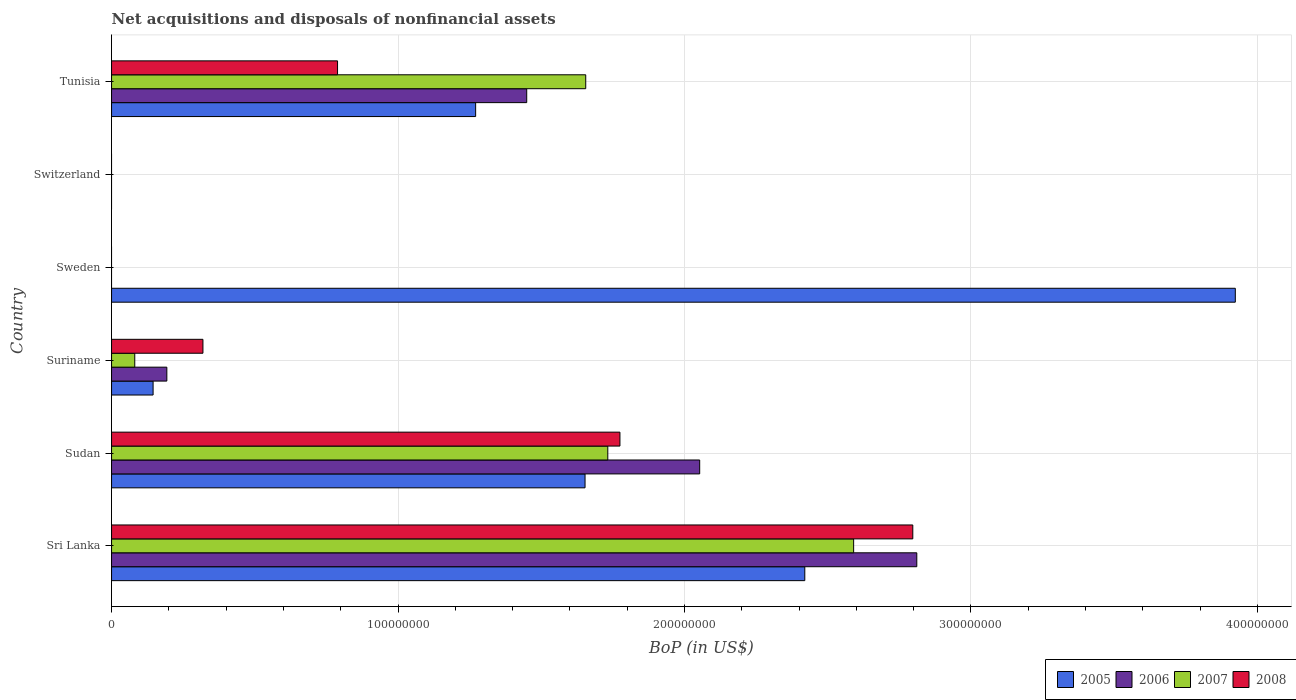How many different coloured bars are there?
Your answer should be compact. 4. Are the number of bars per tick equal to the number of legend labels?
Make the answer very short. No. What is the label of the 3rd group of bars from the top?
Your response must be concise. Sweden. In how many cases, is the number of bars for a given country not equal to the number of legend labels?
Provide a succinct answer. 2. What is the Balance of Payments in 2005 in Sri Lanka?
Provide a short and direct response. 2.42e+08. Across all countries, what is the maximum Balance of Payments in 2007?
Offer a terse response. 2.59e+08. Across all countries, what is the minimum Balance of Payments in 2006?
Your response must be concise. 0. What is the total Balance of Payments in 2005 in the graph?
Keep it short and to the point. 9.41e+08. What is the difference between the Balance of Payments in 2008 in Sri Lanka and that in Suriname?
Your answer should be compact. 2.48e+08. What is the difference between the Balance of Payments in 2005 in Switzerland and the Balance of Payments in 2008 in Sudan?
Make the answer very short. -1.77e+08. What is the average Balance of Payments in 2006 per country?
Ensure brevity in your answer.  1.08e+08. What is the difference between the Balance of Payments in 2008 and Balance of Payments in 2005 in Tunisia?
Offer a very short reply. -4.82e+07. In how many countries, is the Balance of Payments in 2005 greater than 300000000 US$?
Your response must be concise. 1. What is the ratio of the Balance of Payments in 2006 in Sri Lanka to that in Sudan?
Provide a succinct answer. 1.37. Is the Balance of Payments in 2006 in Suriname less than that in Tunisia?
Ensure brevity in your answer.  Yes. Is the difference between the Balance of Payments in 2008 in Suriname and Tunisia greater than the difference between the Balance of Payments in 2005 in Suriname and Tunisia?
Offer a very short reply. Yes. What is the difference between the highest and the second highest Balance of Payments in 2007?
Offer a very short reply. 8.58e+07. What is the difference between the highest and the lowest Balance of Payments in 2008?
Make the answer very short. 2.80e+08. Is the sum of the Balance of Payments in 2005 in Sudan and Sweden greater than the maximum Balance of Payments in 2008 across all countries?
Your answer should be very brief. Yes. Is it the case that in every country, the sum of the Balance of Payments in 2005 and Balance of Payments in 2008 is greater than the sum of Balance of Payments in 2006 and Balance of Payments in 2007?
Your answer should be very brief. No. Is it the case that in every country, the sum of the Balance of Payments in 2006 and Balance of Payments in 2008 is greater than the Balance of Payments in 2007?
Your response must be concise. No. How many countries are there in the graph?
Offer a very short reply. 6. What is the difference between two consecutive major ticks on the X-axis?
Offer a very short reply. 1.00e+08. Does the graph contain any zero values?
Provide a succinct answer. Yes. Where does the legend appear in the graph?
Ensure brevity in your answer.  Bottom right. What is the title of the graph?
Provide a succinct answer. Net acquisitions and disposals of nonfinancial assets. What is the label or title of the X-axis?
Make the answer very short. BoP (in US$). What is the label or title of the Y-axis?
Provide a short and direct response. Country. What is the BoP (in US$) in 2005 in Sri Lanka?
Provide a short and direct response. 2.42e+08. What is the BoP (in US$) in 2006 in Sri Lanka?
Give a very brief answer. 2.81e+08. What is the BoP (in US$) of 2007 in Sri Lanka?
Provide a short and direct response. 2.59e+08. What is the BoP (in US$) in 2008 in Sri Lanka?
Your response must be concise. 2.80e+08. What is the BoP (in US$) of 2005 in Sudan?
Your answer should be very brief. 1.65e+08. What is the BoP (in US$) of 2006 in Sudan?
Ensure brevity in your answer.  2.05e+08. What is the BoP (in US$) of 2007 in Sudan?
Provide a short and direct response. 1.73e+08. What is the BoP (in US$) of 2008 in Sudan?
Your answer should be very brief. 1.77e+08. What is the BoP (in US$) in 2005 in Suriname?
Give a very brief answer. 1.45e+07. What is the BoP (in US$) in 2006 in Suriname?
Provide a short and direct response. 1.93e+07. What is the BoP (in US$) of 2007 in Suriname?
Give a very brief answer. 8.10e+06. What is the BoP (in US$) in 2008 in Suriname?
Your answer should be compact. 3.19e+07. What is the BoP (in US$) in 2005 in Sweden?
Make the answer very short. 3.92e+08. What is the BoP (in US$) of 2008 in Sweden?
Provide a succinct answer. 0. What is the BoP (in US$) in 2005 in Switzerland?
Your response must be concise. 0. What is the BoP (in US$) in 2005 in Tunisia?
Offer a terse response. 1.27e+08. What is the BoP (in US$) in 2006 in Tunisia?
Offer a terse response. 1.45e+08. What is the BoP (in US$) of 2007 in Tunisia?
Provide a succinct answer. 1.66e+08. What is the BoP (in US$) of 2008 in Tunisia?
Offer a terse response. 7.89e+07. Across all countries, what is the maximum BoP (in US$) of 2005?
Ensure brevity in your answer.  3.92e+08. Across all countries, what is the maximum BoP (in US$) in 2006?
Ensure brevity in your answer.  2.81e+08. Across all countries, what is the maximum BoP (in US$) in 2007?
Ensure brevity in your answer.  2.59e+08. Across all countries, what is the maximum BoP (in US$) of 2008?
Ensure brevity in your answer.  2.80e+08. What is the total BoP (in US$) of 2005 in the graph?
Your response must be concise. 9.41e+08. What is the total BoP (in US$) in 2006 in the graph?
Keep it short and to the point. 6.51e+08. What is the total BoP (in US$) in 2007 in the graph?
Your answer should be very brief. 6.06e+08. What is the total BoP (in US$) of 2008 in the graph?
Offer a terse response. 5.68e+08. What is the difference between the BoP (in US$) of 2005 in Sri Lanka and that in Sudan?
Ensure brevity in your answer.  7.67e+07. What is the difference between the BoP (in US$) of 2006 in Sri Lanka and that in Sudan?
Offer a very short reply. 7.58e+07. What is the difference between the BoP (in US$) in 2007 in Sri Lanka and that in Sudan?
Provide a short and direct response. 8.58e+07. What is the difference between the BoP (in US$) of 2008 in Sri Lanka and that in Sudan?
Your answer should be compact. 1.02e+08. What is the difference between the BoP (in US$) of 2005 in Sri Lanka and that in Suriname?
Provide a succinct answer. 2.28e+08. What is the difference between the BoP (in US$) of 2006 in Sri Lanka and that in Suriname?
Offer a very short reply. 2.62e+08. What is the difference between the BoP (in US$) in 2007 in Sri Lanka and that in Suriname?
Provide a succinct answer. 2.51e+08. What is the difference between the BoP (in US$) in 2008 in Sri Lanka and that in Suriname?
Give a very brief answer. 2.48e+08. What is the difference between the BoP (in US$) in 2005 in Sri Lanka and that in Sweden?
Offer a terse response. -1.50e+08. What is the difference between the BoP (in US$) of 2005 in Sri Lanka and that in Tunisia?
Offer a very short reply. 1.15e+08. What is the difference between the BoP (in US$) in 2006 in Sri Lanka and that in Tunisia?
Keep it short and to the point. 1.36e+08. What is the difference between the BoP (in US$) of 2007 in Sri Lanka and that in Tunisia?
Keep it short and to the point. 9.35e+07. What is the difference between the BoP (in US$) of 2008 in Sri Lanka and that in Tunisia?
Offer a very short reply. 2.01e+08. What is the difference between the BoP (in US$) in 2005 in Sudan and that in Suriname?
Your answer should be compact. 1.51e+08. What is the difference between the BoP (in US$) in 2006 in Sudan and that in Suriname?
Offer a terse response. 1.86e+08. What is the difference between the BoP (in US$) of 2007 in Sudan and that in Suriname?
Provide a succinct answer. 1.65e+08. What is the difference between the BoP (in US$) in 2008 in Sudan and that in Suriname?
Your answer should be very brief. 1.46e+08. What is the difference between the BoP (in US$) of 2005 in Sudan and that in Sweden?
Make the answer very short. -2.27e+08. What is the difference between the BoP (in US$) of 2005 in Sudan and that in Tunisia?
Ensure brevity in your answer.  3.82e+07. What is the difference between the BoP (in US$) of 2006 in Sudan and that in Tunisia?
Offer a very short reply. 6.04e+07. What is the difference between the BoP (in US$) of 2007 in Sudan and that in Tunisia?
Give a very brief answer. 7.70e+06. What is the difference between the BoP (in US$) of 2008 in Sudan and that in Tunisia?
Provide a short and direct response. 9.86e+07. What is the difference between the BoP (in US$) in 2005 in Suriname and that in Sweden?
Keep it short and to the point. -3.78e+08. What is the difference between the BoP (in US$) in 2005 in Suriname and that in Tunisia?
Give a very brief answer. -1.13e+08. What is the difference between the BoP (in US$) of 2006 in Suriname and that in Tunisia?
Your response must be concise. -1.26e+08. What is the difference between the BoP (in US$) in 2007 in Suriname and that in Tunisia?
Give a very brief answer. -1.57e+08. What is the difference between the BoP (in US$) of 2008 in Suriname and that in Tunisia?
Your answer should be very brief. -4.70e+07. What is the difference between the BoP (in US$) of 2005 in Sweden and that in Tunisia?
Provide a succinct answer. 2.65e+08. What is the difference between the BoP (in US$) in 2005 in Sri Lanka and the BoP (in US$) in 2006 in Sudan?
Give a very brief answer. 3.67e+07. What is the difference between the BoP (in US$) in 2005 in Sri Lanka and the BoP (in US$) in 2007 in Sudan?
Keep it short and to the point. 6.88e+07. What is the difference between the BoP (in US$) in 2005 in Sri Lanka and the BoP (in US$) in 2008 in Sudan?
Offer a very short reply. 6.45e+07. What is the difference between the BoP (in US$) of 2006 in Sri Lanka and the BoP (in US$) of 2007 in Sudan?
Provide a succinct answer. 1.08e+08. What is the difference between the BoP (in US$) in 2006 in Sri Lanka and the BoP (in US$) in 2008 in Sudan?
Give a very brief answer. 1.04e+08. What is the difference between the BoP (in US$) of 2007 in Sri Lanka and the BoP (in US$) of 2008 in Sudan?
Your response must be concise. 8.16e+07. What is the difference between the BoP (in US$) in 2005 in Sri Lanka and the BoP (in US$) in 2006 in Suriname?
Your response must be concise. 2.23e+08. What is the difference between the BoP (in US$) in 2005 in Sri Lanka and the BoP (in US$) in 2007 in Suriname?
Provide a short and direct response. 2.34e+08. What is the difference between the BoP (in US$) in 2005 in Sri Lanka and the BoP (in US$) in 2008 in Suriname?
Your answer should be compact. 2.10e+08. What is the difference between the BoP (in US$) in 2006 in Sri Lanka and the BoP (in US$) in 2007 in Suriname?
Offer a terse response. 2.73e+08. What is the difference between the BoP (in US$) of 2006 in Sri Lanka and the BoP (in US$) of 2008 in Suriname?
Offer a very short reply. 2.49e+08. What is the difference between the BoP (in US$) of 2007 in Sri Lanka and the BoP (in US$) of 2008 in Suriname?
Provide a succinct answer. 2.27e+08. What is the difference between the BoP (in US$) in 2005 in Sri Lanka and the BoP (in US$) in 2006 in Tunisia?
Offer a very short reply. 9.71e+07. What is the difference between the BoP (in US$) in 2005 in Sri Lanka and the BoP (in US$) in 2007 in Tunisia?
Offer a terse response. 7.65e+07. What is the difference between the BoP (in US$) of 2005 in Sri Lanka and the BoP (in US$) of 2008 in Tunisia?
Provide a succinct answer. 1.63e+08. What is the difference between the BoP (in US$) in 2006 in Sri Lanka and the BoP (in US$) in 2007 in Tunisia?
Ensure brevity in your answer.  1.16e+08. What is the difference between the BoP (in US$) in 2006 in Sri Lanka and the BoP (in US$) in 2008 in Tunisia?
Make the answer very short. 2.02e+08. What is the difference between the BoP (in US$) of 2007 in Sri Lanka and the BoP (in US$) of 2008 in Tunisia?
Offer a terse response. 1.80e+08. What is the difference between the BoP (in US$) of 2005 in Sudan and the BoP (in US$) of 2006 in Suriname?
Provide a succinct answer. 1.46e+08. What is the difference between the BoP (in US$) in 2005 in Sudan and the BoP (in US$) in 2007 in Suriname?
Keep it short and to the point. 1.57e+08. What is the difference between the BoP (in US$) of 2005 in Sudan and the BoP (in US$) of 2008 in Suriname?
Give a very brief answer. 1.33e+08. What is the difference between the BoP (in US$) in 2006 in Sudan and the BoP (in US$) in 2007 in Suriname?
Provide a short and direct response. 1.97e+08. What is the difference between the BoP (in US$) in 2006 in Sudan and the BoP (in US$) in 2008 in Suriname?
Your answer should be compact. 1.73e+08. What is the difference between the BoP (in US$) of 2007 in Sudan and the BoP (in US$) of 2008 in Suriname?
Offer a terse response. 1.41e+08. What is the difference between the BoP (in US$) of 2005 in Sudan and the BoP (in US$) of 2006 in Tunisia?
Your response must be concise. 2.04e+07. What is the difference between the BoP (in US$) in 2005 in Sudan and the BoP (in US$) in 2007 in Tunisia?
Provide a short and direct response. -2.41e+05. What is the difference between the BoP (in US$) of 2005 in Sudan and the BoP (in US$) of 2008 in Tunisia?
Provide a short and direct response. 8.64e+07. What is the difference between the BoP (in US$) of 2006 in Sudan and the BoP (in US$) of 2007 in Tunisia?
Give a very brief answer. 3.98e+07. What is the difference between the BoP (in US$) of 2006 in Sudan and the BoP (in US$) of 2008 in Tunisia?
Your answer should be compact. 1.26e+08. What is the difference between the BoP (in US$) in 2007 in Sudan and the BoP (in US$) in 2008 in Tunisia?
Provide a short and direct response. 9.43e+07. What is the difference between the BoP (in US$) of 2005 in Suriname and the BoP (in US$) of 2006 in Tunisia?
Ensure brevity in your answer.  -1.30e+08. What is the difference between the BoP (in US$) of 2005 in Suriname and the BoP (in US$) of 2007 in Tunisia?
Make the answer very short. -1.51e+08. What is the difference between the BoP (in US$) in 2005 in Suriname and the BoP (in US$) in 2008 in Tunisia?
Provide a short and direct response. -6.44e+07. What is the difference between the BoP (in US$) in 2006 in Suriname and the BoP (in US$) in 2007 in Tunisia?
Offer a terse response. -1.46e+08. What is the difference between the BoP (in US$) of 2006 in Suriname and the BoP (in US$) of 2008 in Tunisia?
Your answer should be compact. -5.96e+07. What is the difference between the BoP (in US$) of 2007 in Suriname and the BoP (in US$) of 2008 in Tunisia?
Keep it short and to the point. -7.08e+07. What is the difference between the BoP (in US$) in 2005 in Sweden and the BoP (in US$) in 2006 in Tunisia?
Your response must be concise. 2.47e+08. What is the difference between the BoP (in US$) in 2005 in Sweden and the BoP (in US$) in 2007 in Tunisia?
Keep it short and to the point. 2.27e+08. What is the difference between the BoP (in US$) of 2005 in Sweden and the BoP (in US$) of 2008 in Tunisia?
Provide a succinct answer. 3.13e+08. What is the average BoP (in US$) of 2005 per country?
Your answer should be compact. 1.57e+08. What is the average BoP (in US$) in 2006 per country?
Your answer should be very brief. 1.08e+08. What is the average BoP (in US$) in 2007 per country?
Keep it short and to the point. 1.01e+08. What is the average BoP (in US$) in 2008 per country?
Provide a short and direct response. 9.47e+07. What is the difference between the BoP (in US$) in 2005 and BoP (in US$) in 2006 in Sri Lanka?
Provide a short and direct response. -3.91e+07. What is the difference between the BoP (in US$) of 2005 and BoP (in US$) of 2007 in Sri Lanka?
Make the answer very short. -1.70e+07. What is the difference between the BoP (in US$) of 2005 and BoP (in US$) of 2008 in Sri Lanka?
Your response must be concise. -3.77e+07. What is the difference between the BoP (in US$) in 2006 and BoP (in US$) in 2007 in Sri Lanka?
Provide a succinct answer. 2.20e+07. What is the difference between the BoP (in US$) in 2006 and BoP (in US$) in 2008 in Sri Lanka?
Make the answer very short. 1.40e+06. What is the difference between the BoP (in US$) in 2007 and BoP (in US$) in 2008 in Sri Lanka?
Keep it short and to the point. -2.06e+07. What is the difference between the BoP (in US$) of 2005 and BoP (in US$) of 2006 in Sudan?
Your answer should be very brief. -4.00e+07. What is the difference between the BoP (in US$) in 2005 and BoP (in US$) in 2007 in Sudan?
Give a very brief answer. -7.94e+06. What is the difference between the BoP (in US$) in 2005 and BoP (in US$) in 2008 in Sudan?
Offer a very short reply. -1.22e+07. What is the difference between the BoP (in US$) of 2006 and BoP (in US$) of 2007 in Sudan?
Ensure brevity in your answer.  3.21e+07. What is the difference between the BoP (in US$) of 2006 and BoP (in US$) of 2008 in Sudan?
Offer a very short reply. 2.78e+07. What is the difference between the BoP (in US$) in 2007 and BoP (in US$) in 2008 in Sudan?
Provide a succinct answer. -4.24e+06. What is the difference between the BoP (in US$) of 2005 and BoP (in US$) of 2006 in Suriname?
Offer a very short reply. -4.80e+06. What is the difference between the BoP (in US$) of 2005 and BoP (in US$) of 2007 in Suriname?
Provide a succinct answer. 6.40e+06. What is the difference between the BoP (in US$) of 2005 and BoP (in US$) of 2008 in Suriname?
Offer a terse response. -1.74e+07. What is the difference between the BoP (in US$) in 2006 and BoP (in US$) in 2007 in Suriname?
Make the answer very short. 1.12e+07. What is the difference between the BoP (in US$) of 2006 and BoP (in US$) of 2008 in Suriname?
Make the answer very short. -1.26e+07. What is the difference between the BoP (in US$) of 2007 and BoP (in US$) of 2008 in Suriname?
Provide a succinct answer. -2.38e+07. What is the difference between the BoP (in US$) in 2005 and BoP (in US$) in 2006 in Tunisia?
Your answer should be very brief. -1.78e+07. What is the difference between the BoP (in US$) of 2005 and BoP (in US$) of 2007 in Tunisia?
Ensure brevity in your answer.  -3.84e+07. What is the difference between the BoP (in US$) of 2005 and BoP (in US$) of 2008 in Tunisia?
Keep it short and to the point. 4.82e+07. What is the difference between the BoP (in US$) of 2006 and BoP (in US$) of 2007 in Tunisia?
Your response must be concise. -2.06e+07. What is the difference between the BoP (in US$) in 2006 and BoP (in US$) in 2008 in Tunisia?
Offer a terse response. 6.60e+07. What is the difference between the BoP (in US$) of 2007 and BoP (in US$) of 2008 in Tunisia?
Your answer should be compact. 8.66e+07. What is the ratio of the BoP (in US$) of 2005 in Sri Lanka to that in Sudan?
Provide a short and direct response. 1.46. What is the ratio of the BoP (in US$) of 2006 in Sri Lanka to that in Sudan?
Provide a succinct answer. 1.37. What is the ratio of the BoP (in US$) in 2007 in Sri Lanka to that in Sudan?
Your answer should be very brief. 1.5. What is the ratio of the BoP (in US$) of 2008 in Sri Lanka to that in Sudan?
Make the answer very short. 1.58. What is the ratio of the BoP (in US$) in 2005 in Sri Lanka to that in Suriname?
Give a very brief answer. 16.69. What is the ratio of the BoP (in US$) in 2006 in Sri Lanka to that in Suriname?
Provide a short and direct response. 14.56. What is the ratio of the BoP (in US$) in 2007 in Sri Lanka to that in Suriname?
Your answer should be compact. 31.98. What is the ratio of the BoP (in US$) in 2008 in Sri Lanka to that in Suriname?
Your response must be concise. 8.77. What is the ratio of the BoP (in US$) of 2005 in Sri Lanka to that in Sweden?
Your answer should be very brief. 0.62. What is the ratio of the BoP (in US$) of 2005 in Sri Lanka to that in Tunisia?
Give a very brief answer. 1.9. What is the ratio of the BoP (in US$) of 2006 in Sri Lanka to that in Tunisia?
Offer a terse response. 1.94. What is the ratio of the BoP (in US$) in 2007 in Sri Lanka to that in Tunisia?
Offer a very short reply. 1.56. What is the ratio of the BoP (in US$) in 2008 in Sri Lanka to that in Tunisia?
Provide a succinct answer. 3.55. What is the ratio of the BoP (in US$) of 2005 in Sudan to that in Suriname?
Offer a terse response. 11.4. What is the ratio of the BoP (in US$) of 2006 in Sudan to that in Suriname?
Make the answer very short. 10.64. What is the ratio of the BoP (in US$) of 2007 in Sudan to that in Suriname?
Offer a terse response. 21.39. What is the ratio of the BoP (in US$) of 2008 in Sudan to that in Suriname?
Offer a terse response. 5.56. What is the ratio of the BoP (in US$) of 2005 in Sudan to that in Sweden?
Your response must be concise. 0.42. What is the ratio of the BoP (in US$) in 2005 in Sudan to that in Tunisia?
Your response must be concise. 1.3. What is the ratio of the BoP (in US$) in 2006 in Sudan to that in Tunisia?
Your answer should be compact. 1.42. What is the ratio of the BoP (in US$) in 2007 in Sudan to that in Tunisia?
Ensure brevity in your answer.  1.05. What is the ratio of the BoP (in US$) of 2008 in Sudan to that in Tunisia?
Keep it short and to the point. 2.25. What is the ratio of the BoP (in US$) in 2005 in Suriname to that in Sweden?
Offer a terse response. 0.04. What is the ratio of the BoP (in US$) of 2005 in Suriname to that in Tunisia?
Provide a short and direct response. 0.11. What is the ratio of the BoP (in US$) in 2006 in Suriname to that in Tunisia?
Provide a short and direct response. 0.13. What is the ratio of the BoP (in US$) of 2007 in Suriname to that in Tunisia?
Your answer should be compact. 0.05. What is the ratio of the BoP (in US$) in 2008 in Suriname to that in Tunisia?
Your response must be concise. 0.4. What is the ratio of the BoP (in US$) of 2005 in Sweden to that in Tunisia?
Offer a very short reply. 3.09. What is the difference between the highest and the second highest BoP (in US$) of 2005?
Make the answer very short. 1.50e+08. What is the difference between the highest and the second highest BoP (in US$) in 2006?
Your answer should be compact. 7.58e+07. What is the difference between the highest and the second highest BoP (in US$) of 2007?
Ensure brevity in your answer.  8.58e+07. What is the difference between the highest and the second highest BoP (in US$) of 2008?
Your answer should be compact. 1.02e+08. What is the difference between the highest and the lowest BoP (in US$) in 2005?
Offer a terse response. 3.92e+08. What is the difference between the highest and the lowest BoP (in US$) in 2006?
Offer a terse response. 2.81e+08. What is the difference between the highest and the lowest BoP (in US$) in 2007?
Your response must be concise. 2.59e+08. What is the difference between the highest and the lowest BoP (in US$) in 2008?
Offer a very short reply. 2.80e+08. 